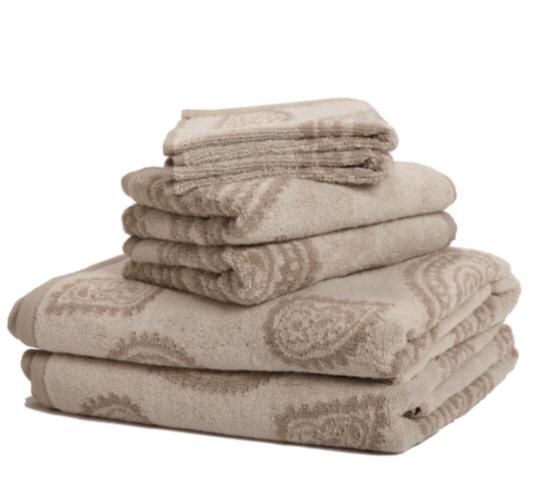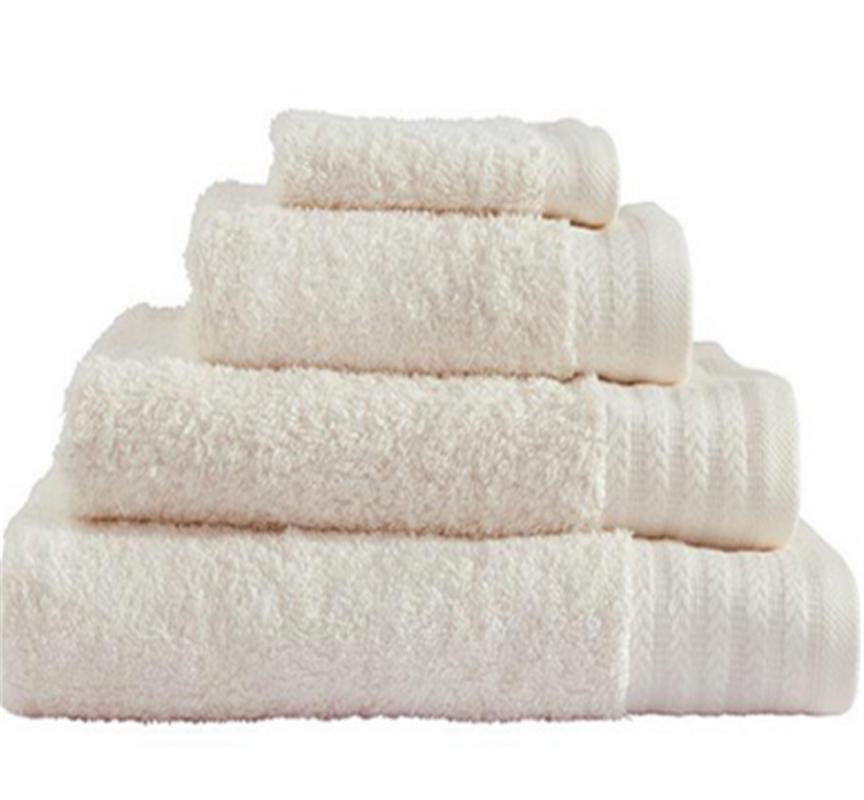The first image is the image on the left, the second image is the image on the right. Given the left and right images, does the statement "Each image contains different towel sizes, and at least one image shows at least three different towel sizes in one stack." hold true? Answer yes or no. Yes. The first image is the image on the left, the second image is the image on the right. Assess this claim about the two images: "There are 4 bath-towels of equal size stacked on top of each other". Correct or not? Answer yes or no. No. 